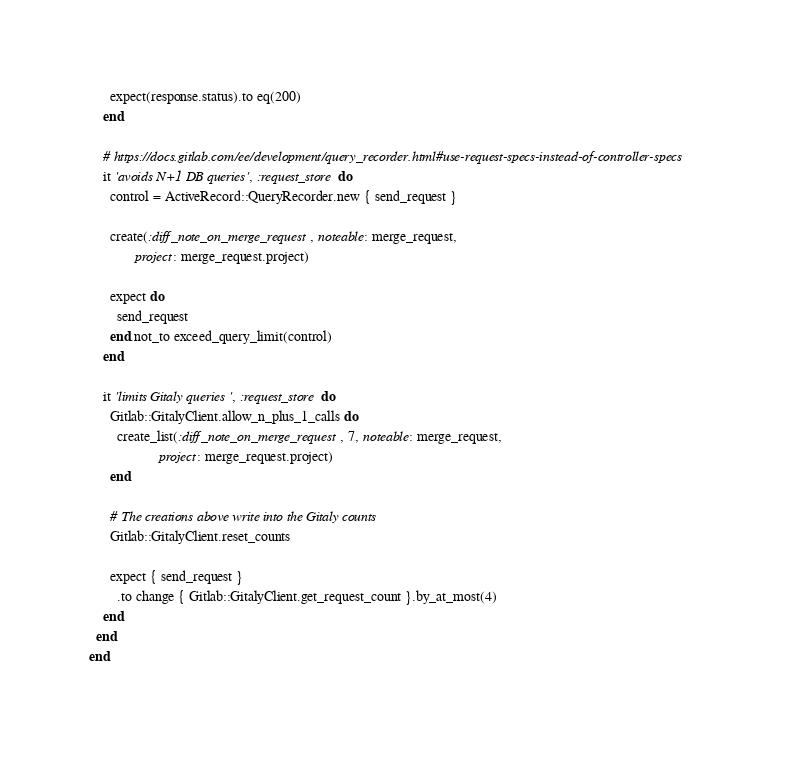<code> <loc_0><loc_0><loc_500><loc_500><_Ruby_>
      expect(response.status).to eq(200)
    end

    # https://docs.gitlab.com/ee/development/query_recorder.html#use-request-specs-instead-of-controller-specs
    it 'avoids N+1 DB queries', :request_store do
      control = ActiveRecord::QueryRecorder.new { send_request }

      create(:diff_note_on_merge_request, noteable: merge_request,
             project: merge_request.project)

      expect do
        send_request
      end.not_to exceed_query_limit(control)
    end

    it 'limits Gitaly queries', :request_store do
      Gitlab::GitalyClient.allow_n_plus_1_calls do
        create_list(:diff_note_on_merge_request, 7, noteable: merge_request,
                    project: merge_request.project)
      end

      # The creations above write into the Gitaly counts
      Gitlab::GitalyClient.reset_counts

      expect { send_request }
        .to change { Gitlab::GitalyClient.get_request_count }.by_at_most(4)
    end
  end
end
</code> 